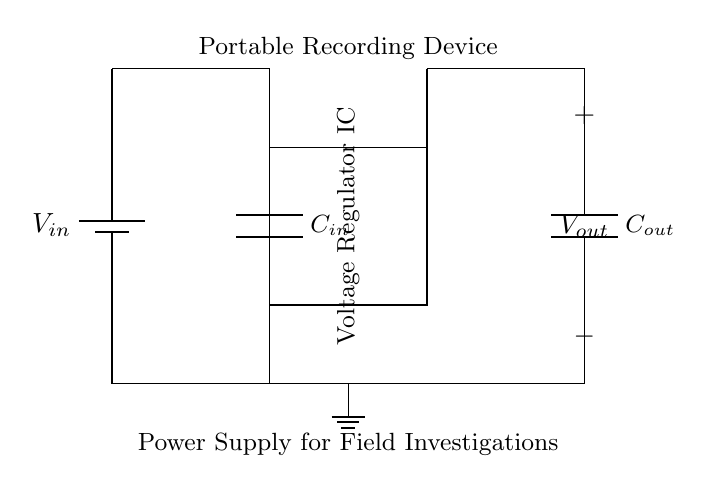What type of device is being powered? The diagram indicates that a portable recording device is being powered, as labeled near the output terminals.
Answer: Portable recording device How many capacitors are present in the circuit? Upon examining the diagram, there are two capacitors present: one labeled as the input capacitor and the other as the output capacitor.
Answer: Two What is the primary function of the voltage regulator IC? The voltage regulator IC is designed to maintain a steady output voltage regardless of variations in the input voltage or load current, ensuring reliable operation for the connected device.
Answer: Maintain steady voltage What is the connection type used for both the input and output capacitors? The connection type for the capacitors is represented as short connections, indicating direct connections between these components and the voltage regulator.
Answer: Short connections What happens to the output voltage if the input voltage increases significantly? If the input voltage increases significantly beyond the specification of the voltage regulator, the output voltage may also increase beyond the desired level, potentially damaging the connected recording device unless the regulator has overvoltage protection.
Answer: Overvoltage risk What is the purpose of the input capacitor in this circuit? The input capacitor is used to filter out voltage spikes and smooth the input supply voltage to the voltage regulator, which helps prevent instability and ensures more consistent operation of the circuit.
Answer: Filtering voltage spikes 